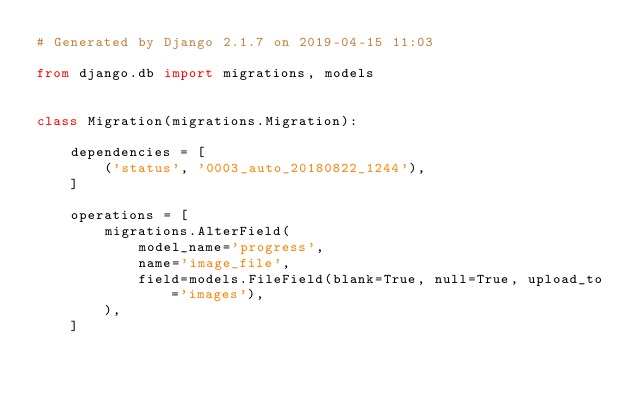<code> <loc_0><loc_0><loc_500><loc_500><_Python_># Generated by Django 2.1.7 on 2019-04-15 11:03

from django.db import migrations, models


class Migration(migrations.Migration):

    dependencies = [
        ('status', '0003_auto_20180822_1244'),
    ]

    operations = [
        migrations.AlterField(
            model_name='progress',
            name='image_file',
            field=models.FileField(blank=True, null=True, upload_to='images'),
        ),
    ]
</code> 